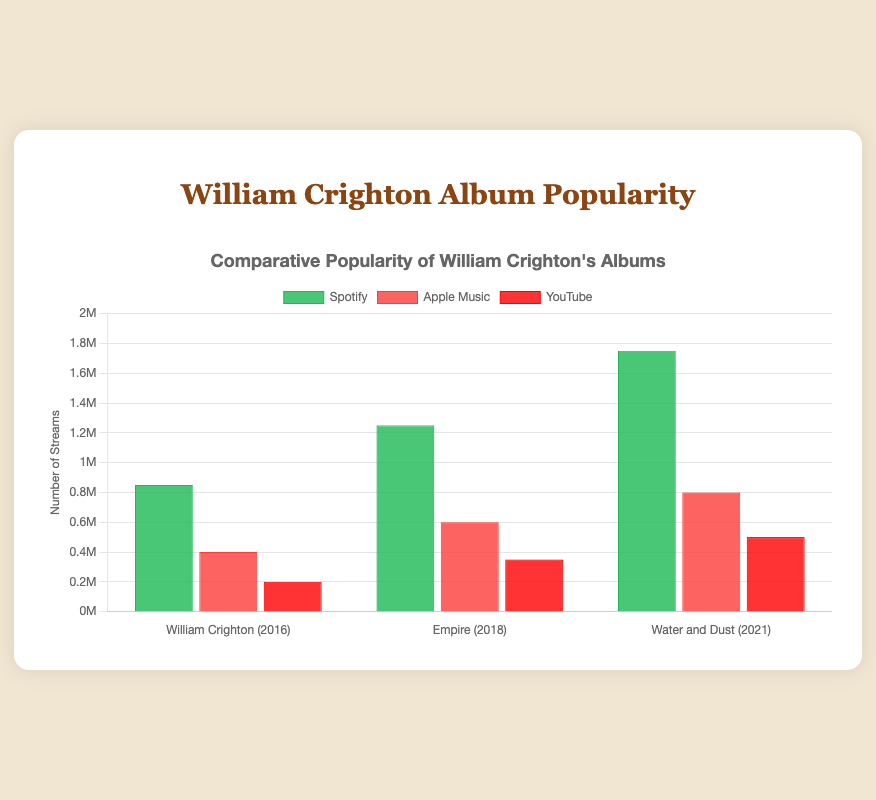Which William Crighton album had the most streams on Spotify in 2021? "Water and Dust" on Spotify had 1,750,000 streams in 2021. Look at the chart and find the green bar for 2021 (Water and Dust) on the Spotify section.
Answer: "Water and Dust" How many streams did "Empire" receive on Apple Music in 2018? "Empire" on Apple Music in 2018 is represented by the red bar for the year 2018. The height of this bar corresponds to 600,000 streams.
Answer: 600,000 Which streaming platform consistently had the most streams for all albums? For each album year - 2016, 2018, and 2021 - the highest bars consistently belong to Spotify (green bars). Checking for each year's top colored bar confirms that Spotify is the platform with the most streams across all albums.
Answer: Spotify What is the total number of streams for the album "William Crighton" across all platforms in 2016? Sum the streams from Spotify (850,000), Apple Music (400,000), and YouTube (200,000). Hence, total streams = 850,000 + 400,000 + 200,000 = 1,450,000.
Answer: 1,450,000 Compare the number of streams between "William Crighton" on YouTube and "Empire" on YouTube. Which one had more streams? "William Crighton" on YouTube in 2016 had 200,000 streams. "Empire" on YouTube in 2018 had 350,000 streams. Compare these numbers, 350,000 is greater than 200,000.
Answer: "Empire" What is the difference in streams between "Water and Dust" on Spotify and Apple Music in 2021? "Water and Dust" on Spotify in 2021 had 1,750,000 streams and on Apple Music had 800,000 streams. The difference is 1,750,000 - 800,000. So, 1,750,000 - 800,000 = 950,000.
Answer: 950,000 Which album had the least number of streams on YouTube across the years? Looking at the red bars representing YouTube streams for each album - 200,000 for 2016, 350,000 for 2018, and 500,000 for 2021 - 200,000 is the smallest value.
Answer: "William Crighton" On which platform did "Water and Dust" see an increase in stream count compared to "Empire"? Compare streams for "Water and Dust" (2021) and "Empire" (2018) across platforms. Spotify increased from 1,250,000 to 1,750,000 and YouTube from 350,000 to 500,000.
Answer: Spotify and YouTube 